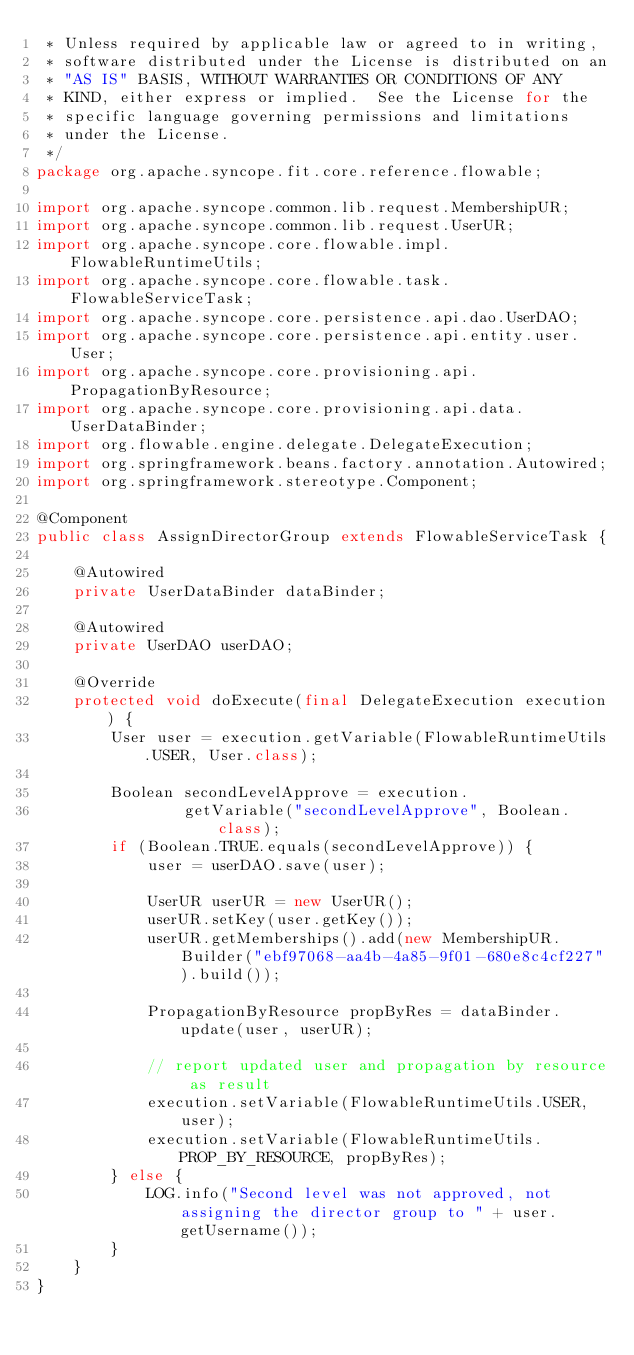Convert code to text. <code><loc_0><loc_0><loc_500><loc_500><_Java_> * Unless required by applicable law or agreed to in writing,
 * software distributed under the License is distributed on an
 * "AS IS" BASIS, WITHOUT WARRANTIES OR CONDITIONS OF ANY
 * KIND, either express or implied.  See the License for the
 * specific language governing permissions and limitations
 * under the License.
 */
package org.apache.syncope.fit.core.reference.flowable;

import org.apache.syncope.common.lib.request.MembershipUR;
import org.apache.syncope.common.lib.request.UserUR;
import org.apache.syncope.core.flowable.impl.FlowableRuntimeUtils;
import org.apache.syncope.core.flowable.task.FlowableServiceTask;
import org.apache.syncope.core.persistence.api.dao.UserDAO;
import org.apache.syncope.core.persistence.api.entity.user.User;
import org.apache.syncope.core.provisioning.api.PropagationByResource;
import org.apache.syncope.core.provisioning.api.data.UserDataBinder;
import org.flowable.engine.delegate.DelegateExecution;
import org.springframework.beans.factory.annotation.Autowired;
import org.springframework.stereotype.Component;

@Component
public class AssignDirectorGroup extends FlowableServiceTask {

    @Autowired
    private UserDataBinder dataBinder;

    @Autowired
    private UserDAO userDAO;

    @Override
    protected void doExecute(final DelegateExecution execution) {
        User user = execution.getVariable(FlowableRuntimeUtils.USER, User.class);

        Boolean secondLevelApprove = execution.
                getVariable("secondLevelApprove", Boolean.class);
        if (Boolean.TRUE.equals(secondLevelApprove)) {
            user = userDAO.save(user);

            UserUR userUR = new UserUR();
            userUR.setKey(user.getKey());
            userUR.getMemberships().add(new MembershipUR.Builder("ebf97068-aa4b-4a85-9f01-680e8c4cf227").build());

            PropagationByResource propByRes = dataBinder.update(user, userUR);

            // report updated user and propagation by resource as result
            execution.setVariable(FlowableRuntimeUtils.USER, user);
            execution.setVariable(FlowableRuntimeUtils.PROP_BY_RESOURCE, propByRes);
        } else {
            LOG.info("Second level was not approved, not assigning the director group to " + user.getUsername());
        }
    }
}
</code> 